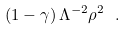<formula> <loc_0><loc_0><loc_500><loc_500>\left ( 1 - \gamma \right ) \Lambda ^ { - 2 } \rho ^ { 2 } \ .</formula> 